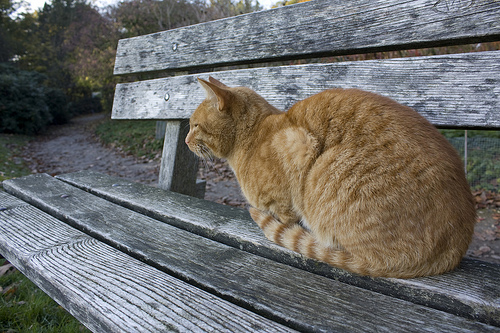Is the weather sunny or partly cloudy today? The weather is sunny today. 